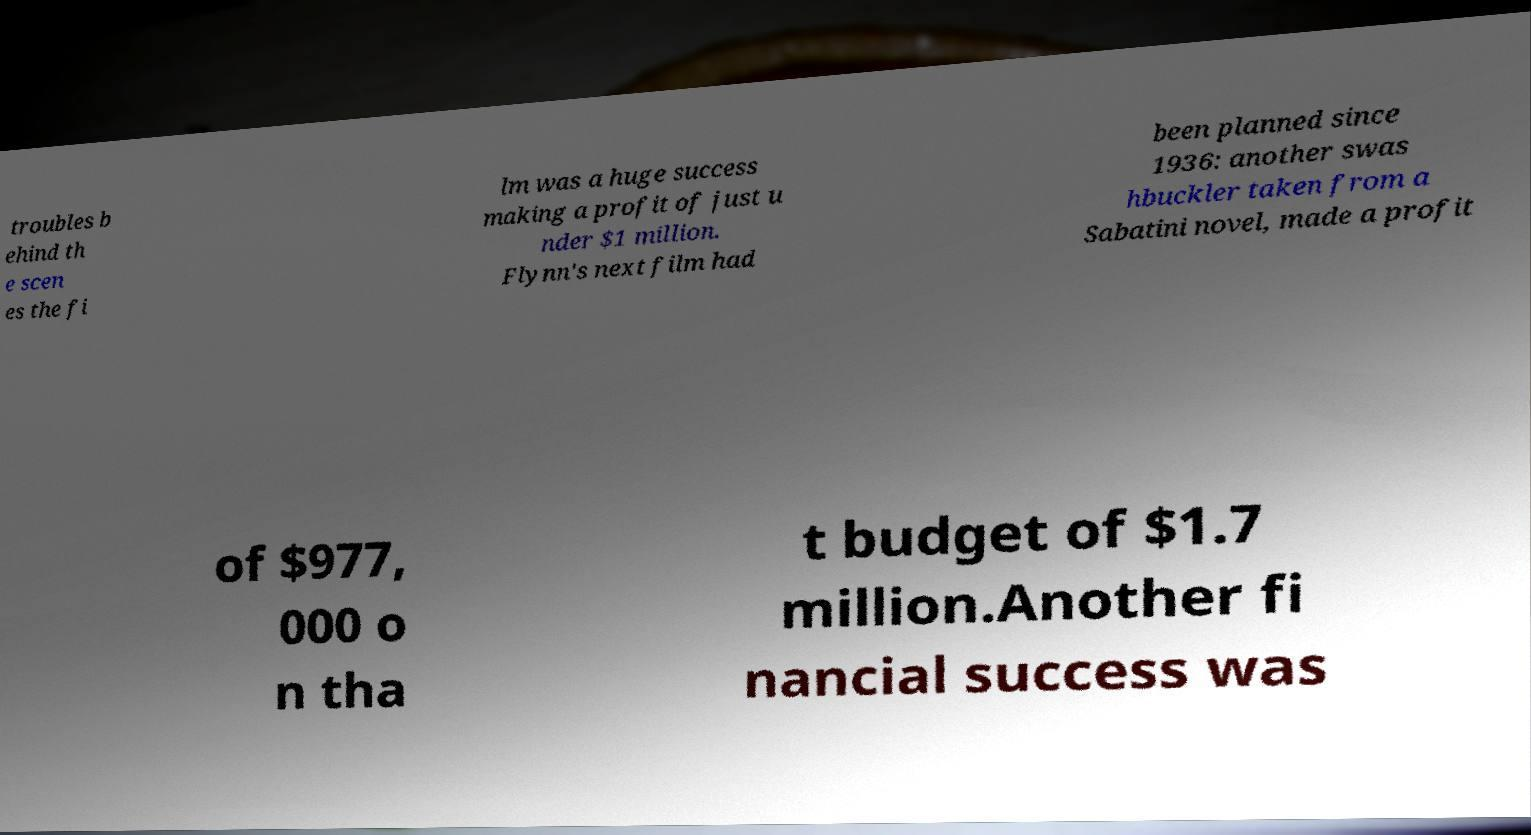What messages or text are displayed in this image? I need them in a readable, typed format. troubles b ehind th e scen es the fi lm was a huge success making a profit of just u nder $1 million. Flynn's next film had been planned since 1936: another swas hbuckler taken from a Sabatini novel, made a profit of $977, 000 o n tha t budget of $1.7 million.Another fi nancial success was 